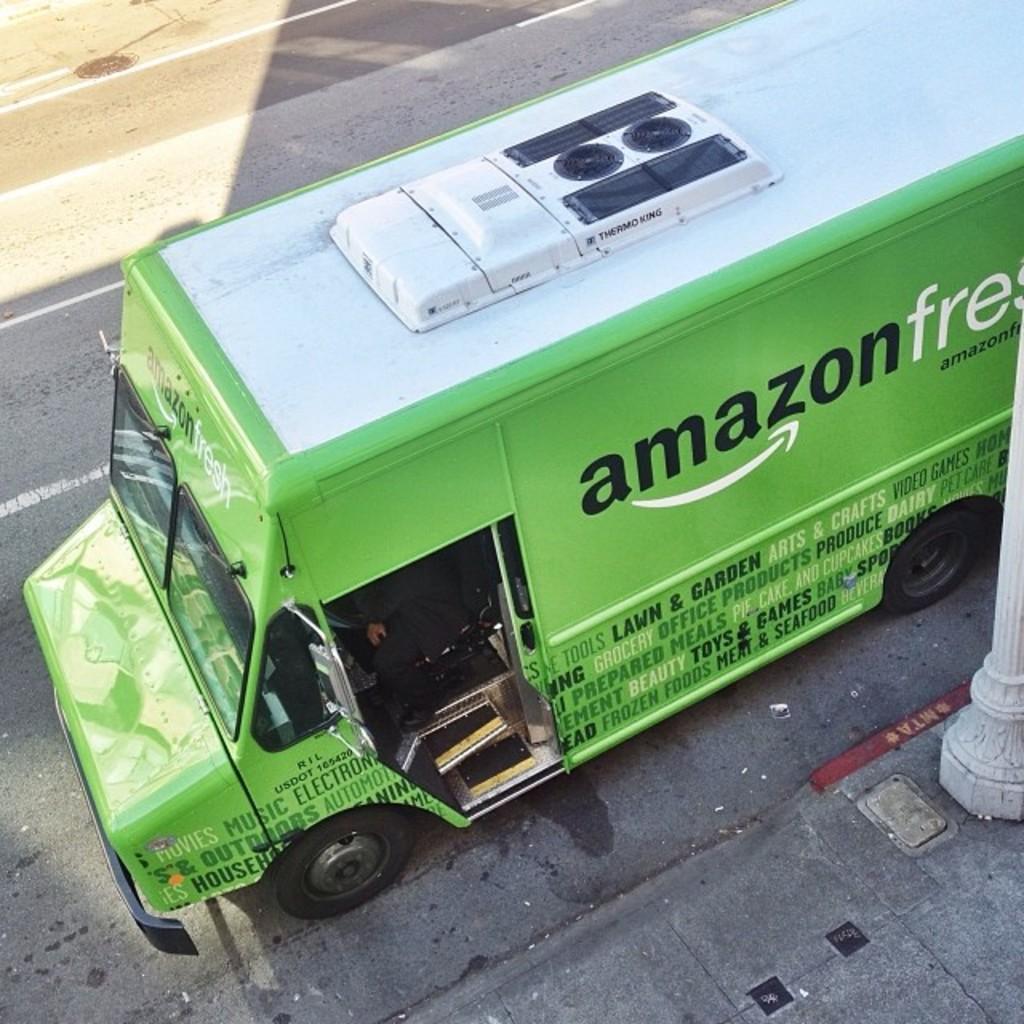In one or two sentences, can you explain what this image depicts? This image consists of a bus in green color. At the bottom, there is a road. And we can see a pavement beside the road. On the right, there is a pillar. 